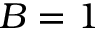<formula> <loc_0><loc_0><loc_500><loc_500>B = 1</formula> 